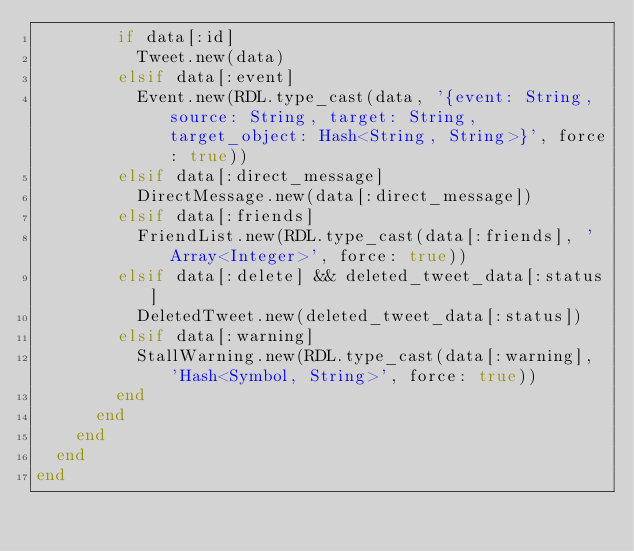<code> <loc_0><loc_0><loc_500><loc_500><_Ruby_>        if data[:id]
          Tweet.new(data)
        elsif data[:event]
          Event.new(RDL.type_cast(data, '{event: String, source: String, target: String, target_object: Hash<String, String>}', force: true))
        elsif data[:direct_message]
          DirectMessage.new(data[:direct_message])
        elsif data[:friends]
          FriendList.new(RDL.type_cast(data[:friends], 'Array<Integer>', force: true))
        elsif data[:delete] && deleted_tweet_data[:status]
          DeletedTweet.new(deleted_tweet_data[:status])
        elsif data[:warning]
          StallWarning.new(RDL.type_cast(data[:warning], 'Hash<Symbol, String>', force: true))
        end
      end
    end
  end
end
</code> 